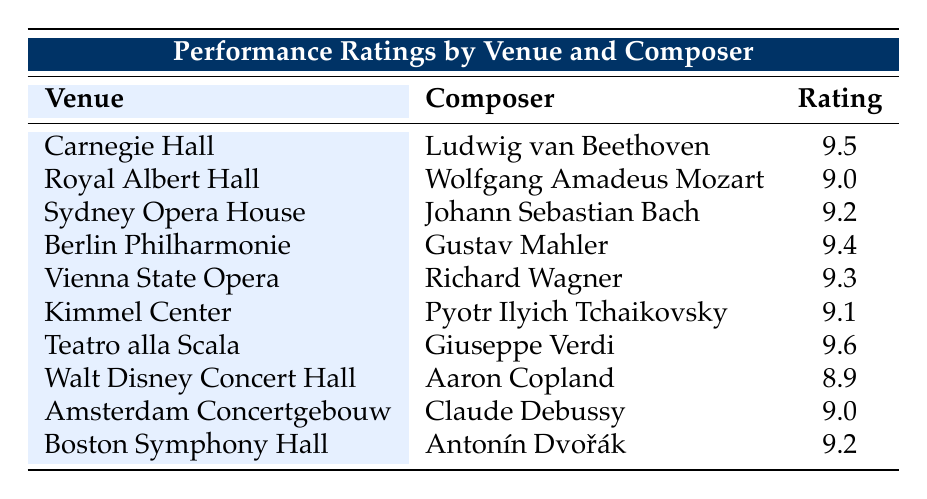What is the performance rating of Ludwig van Beethoven at Carnegie Hall? The table shows that the performance rating associated with Ludwig van Beethoven at Carnegie Hall is 9.5, which is stated directly in the row corresponding to this venue and composer.
Answer: 9.5 Which venue has the highest performance rating and what is it? By examining the performance ratings in the table, the highest rating is found with Giuseppe Verdi at Teatro alla Scala, which has a rating of 9.6.
Answer: Teatro alla Scala, 9.6 What is the average performance rating for all venues listed? To find the average, we sum the performance ratings: 9.5 + 9.0 + 9.2 + 9.4 + 9.3 + 9.1 + 9.6 + 8.9 + 9.0 + 9.2 = 91.0. Since there are 10 venues, the average rating is 91.0 / 10 = 9.1.
Answer: 9.1 Do any composers have a performance rating of 8.9 or lower? The table shows that the only rating below 9.0 is Aaron Copland at Walt Disney Concert Hall, which has a rating of 8.9. Therefore, there is at least one composer with a rating below 9.0.
Answer: Yes What is the difference between the highest and lowest ratings in the table? The highest rating is 9.6 for Giuseppe Verdi at Teatro alla Scala and the lowest rating is 8.9 for Aaron Copland at Walt Disney Concert Hall. The difference is 9.6 - 8.9 = 0.7.
Answer: 0.7 